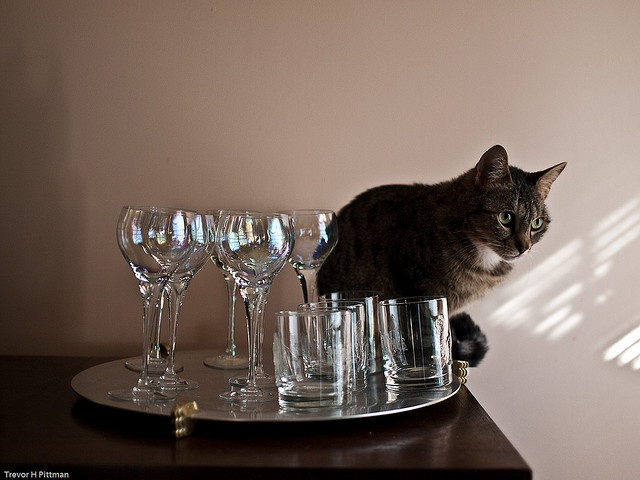Describe the objects in this image and their specific colors. I can see dining table in maroon, black, and gray tones, cat in maroon, black, gray, and darkgray tones, cup in maroon, gray, darkgray, black, and lightgray tones, wine glass in maroon, gray, white, darkgray, and black tones, and cup in maroon, black, gray, lightgray, and darkgray tones in this image. 